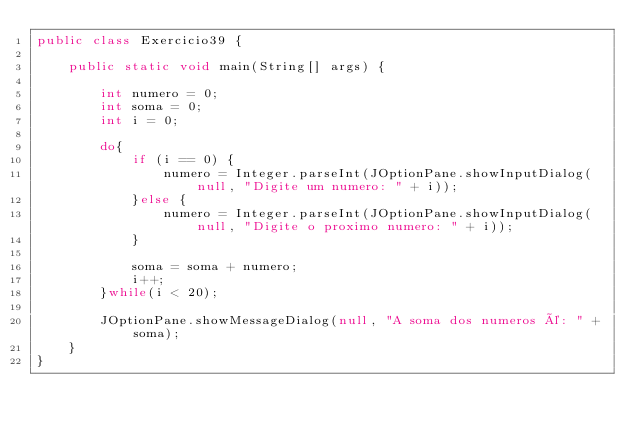Convert code to text. <code><loc_0><loc_0><loc_500><loc_500><_Java_>public class Exercicio39 {
    
    public static void main(String[] args) {
        
        int numero = 0;
        int soma = 0;
        int i = 0;
        
        do{
            if (i == 0) {
                numero = Integer.parseInt(JOptionPane.showInputDialog(null, "Digite um numero: " + i));
            }else {
                numero = Integer.parseInt(JOptionPane.showInputDialog(null, "Digite o proximo numero: " + i));
            }

            soma = soma + numero;
            i++;
        }while(i < 20);
        
        JOptionPane.showMessageDialog(null, "A soma dos numeros é: " + soma);
    }
}
</code> 